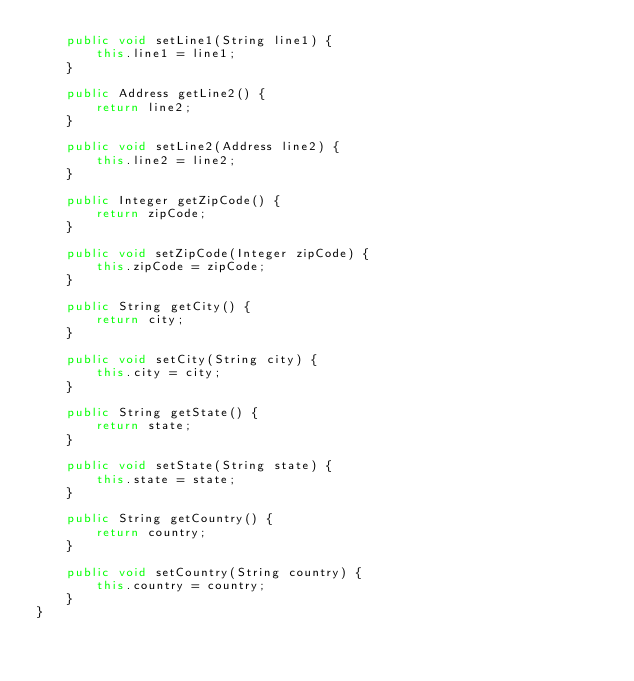<code> <loc_0><loc_0><loc_500><loc_500><_Java_>	public void setLine1(String line1) {
		this.line1 = line1;
	}

	public Address getLine2() {
		return line2;
	}

	public void setLine2(Address line2) {
		this.line2 = line2;
	}

	public Integer getZipCode() {
		return zipCode;
	}

	public void setZipCode(Integer zipCode) {
		this.zipCode = zipCode;
	}

	public String getCity() {
		return city;
	}

	public void setCity(String city) {
		this.city = city;
	}

	public String getState() {
		return state;
	}

	public void setState(String state) {
		this.state = state;
	}

	public String getCountry() {
		return country;
	}

	public void setCountry(String country) {
		this.country = country;
	}
}</code> 